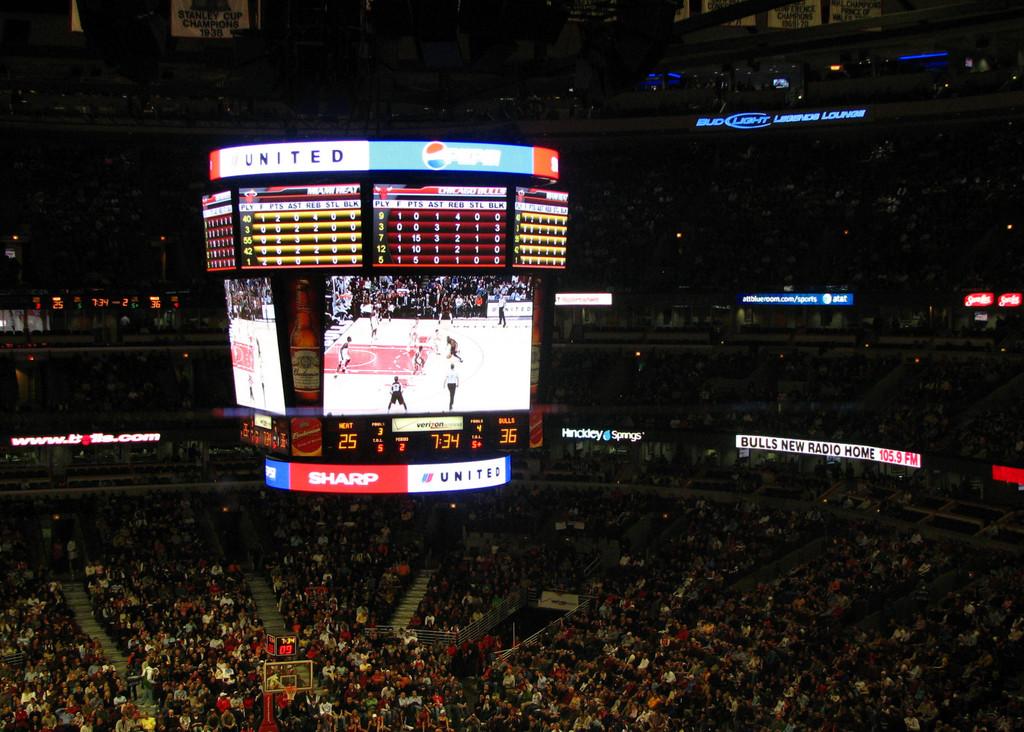What brand is advertised with a red background?
Offer a terse response. Sharp. What soda is a sponsor?
Your answer should be very brief. Pepsi. 